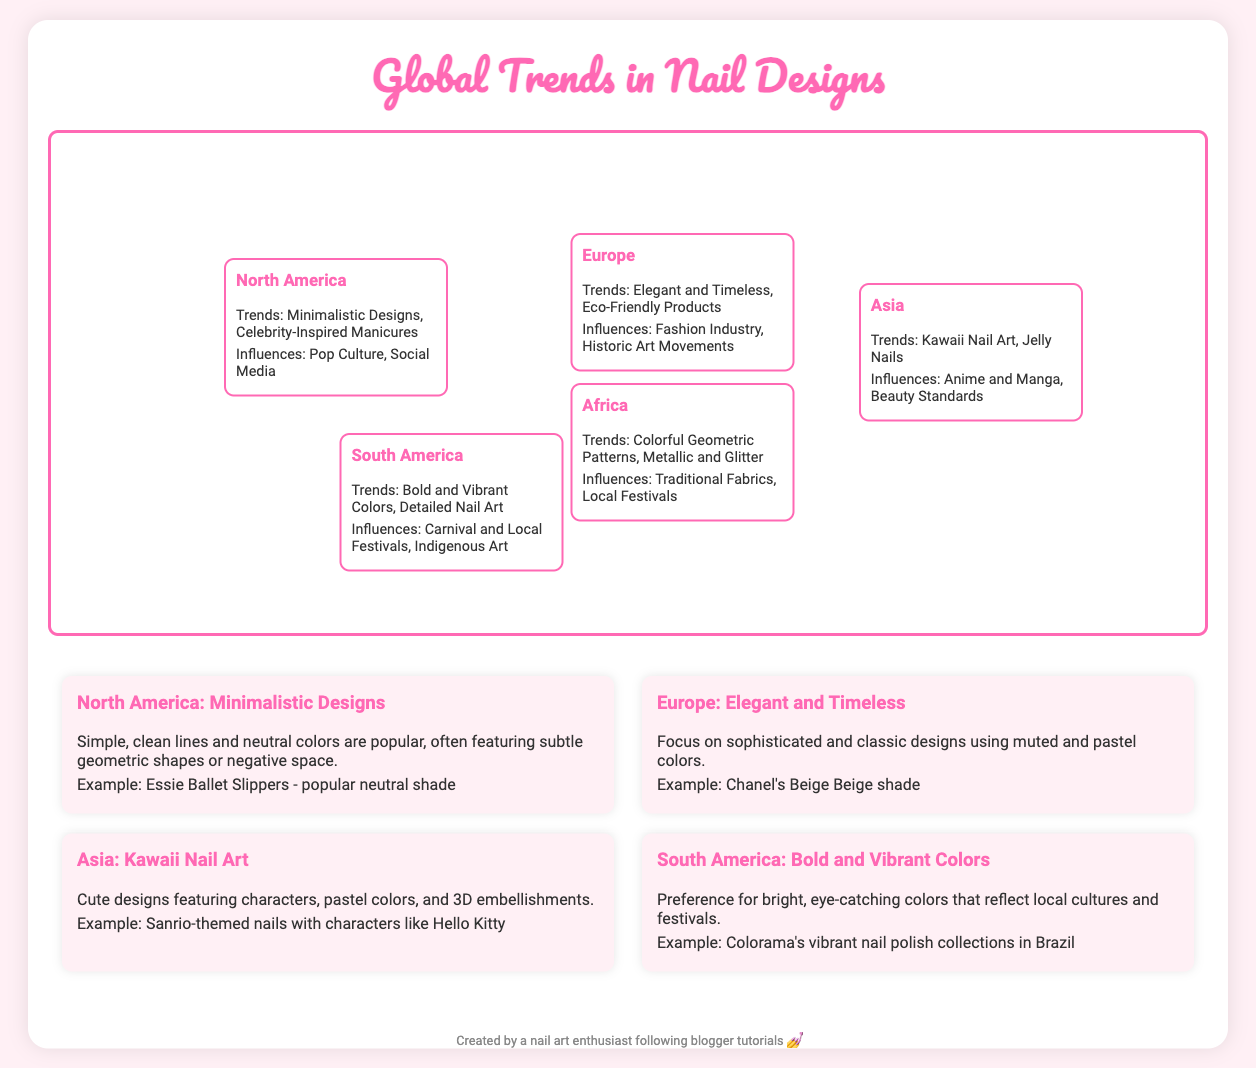What are the popular trends in North America? The trends in North America include Minimalistic Designs and Celebrity-Inspired Manicures.
Answer: Minimalistic Designs, Celebrity-Inspired Manicures What influences nail designs in Europe? The influences in Europe come from the Fashion Industry and Historic Art Movements.
Answer: Fashion Industry, Historic Art Movements Which region features Kawaii Nail Art? Kawaii Nail Art is specifically mentioned as a trend in Asia.
Answer: Asia What type of colors are popular in South America? The popular colors in South America are Bold and Vibrant Colors.
Answer: Bold and Vibrant Colors What example is given for minimalistic designs? The document mentions Essie Ballet Slippers as a popular neutral shade for minimalistic designs.
Answer: Essie Ballet Slippers How do nail trends in Africa reflect cultural influences? Trends in Africa include Colorful Geometric Patterns influenced by Traditional Fabrics and Local Festivals.
Answer: Colorful Geometric Patterns, Traditional Fabrics, Local Festivals Which region is known for detailed nail art? Detailed Nail Art is a trend mentioned for South America.
Answer: South America What type of nail designs does Europe focus on? Europe focuses on Elegant and Timeless designs.
Answer: Elegant and Timeless What are Jelly Nails identified with? Jelly Nails are a trend identified with Asia.
Answer: Jelly Nails 